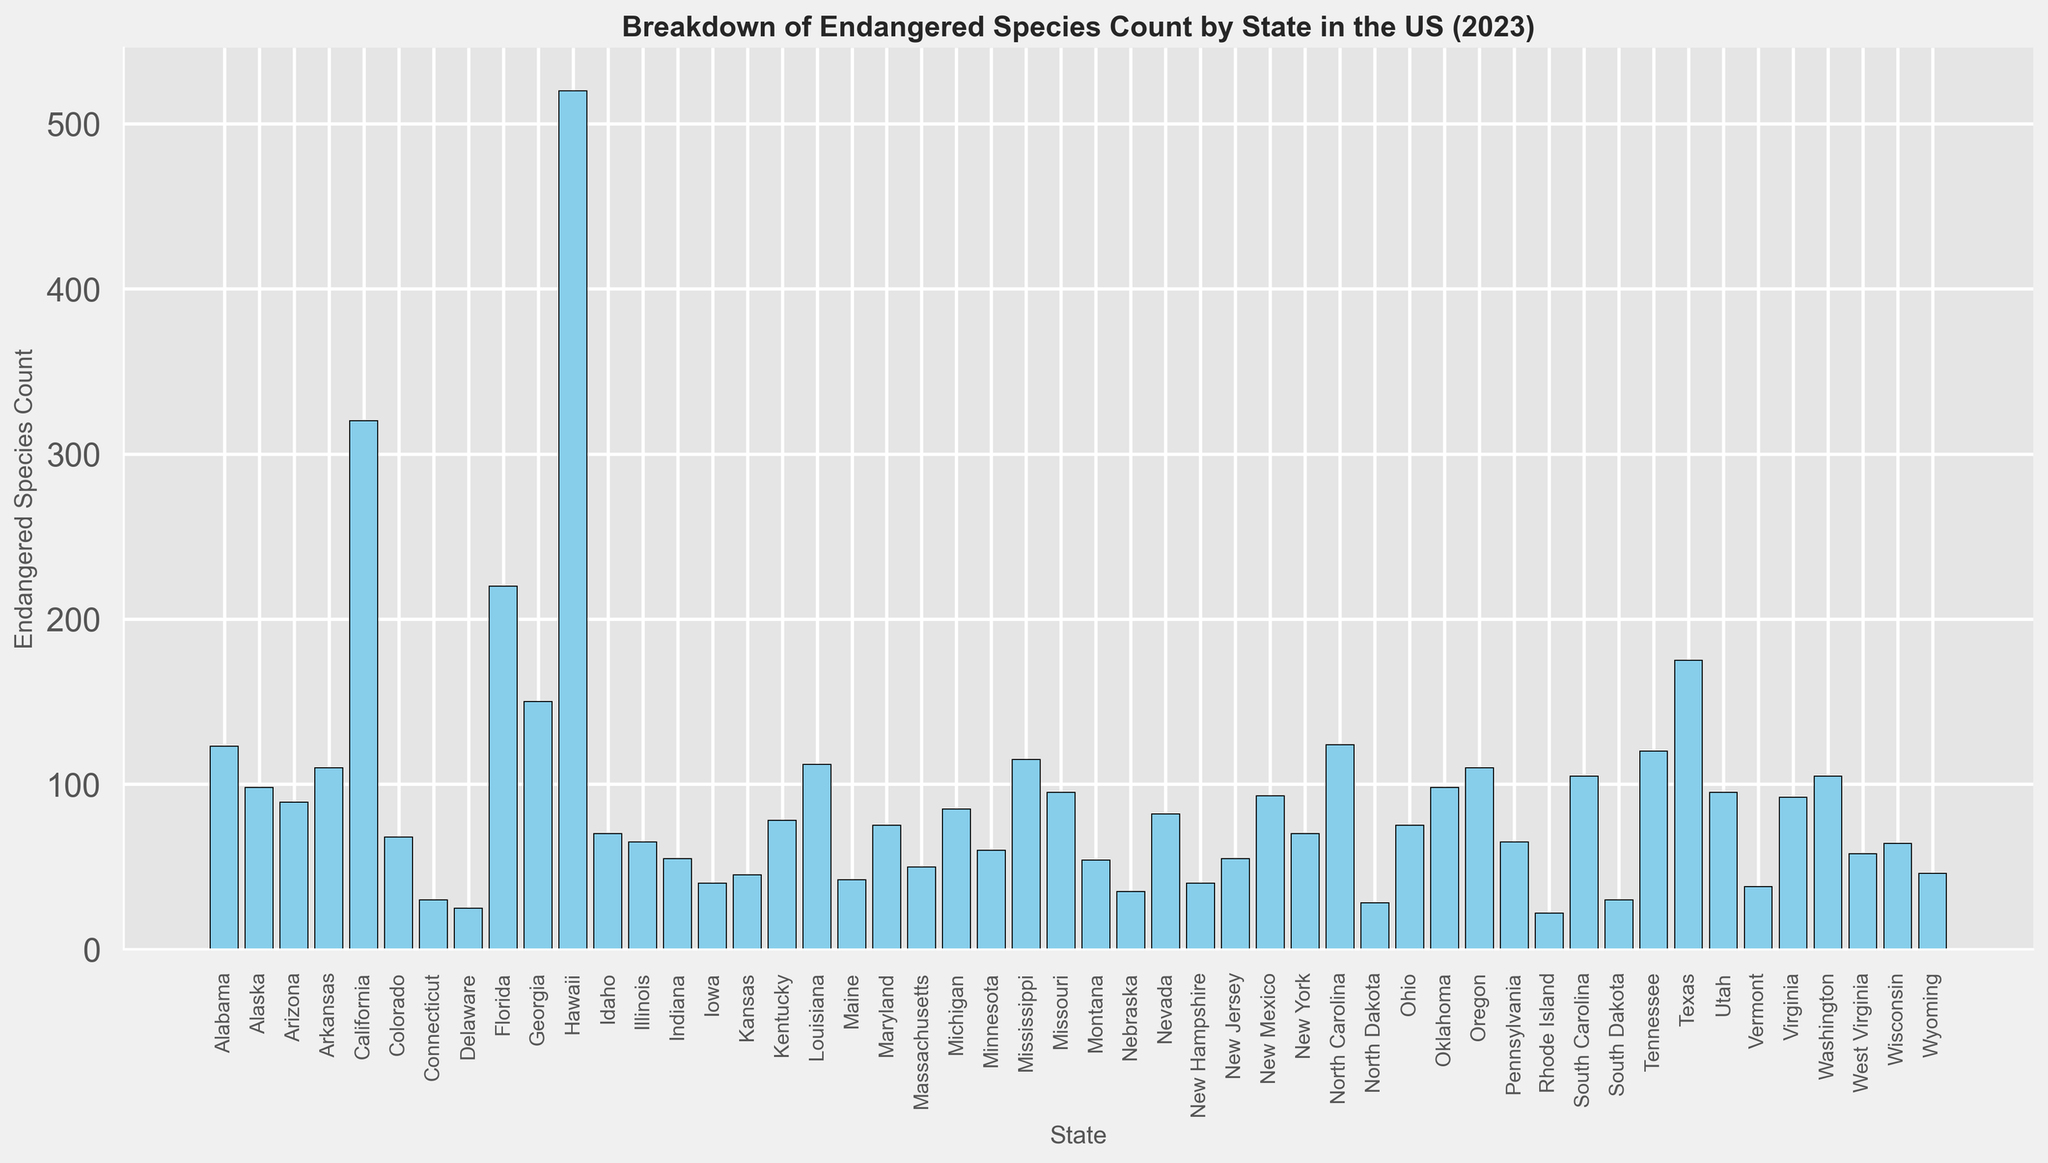What's the state with the highest count of endangered species? To find the state with the highest count, look for the tallest bar in the chart, which represents Hawaii with 520 endangered species.
Answer: Hawaii Which states have an endangered species count greater than 100 but less than 200? Identify the bars that fall within the range of 100 to 200. These states are Georgia (150), Tennessee (120), Texas (175), and North Carolina (124).
Answer: Georgia, Tennessee, Texas, North Carolina How does the endangered species count in California compare to that in Texas? Compare the heights of the bars for California and Texas. California has 320 endangered species, while Texas has 175. Thus, California has more endangered species than Texas.
Answer: California has more How many states have more than 200 endangered species? Count the bars that exceed the height representing 200 endangered species. There are three states: California (320), Florida (220), and Hawaii (520).
Answer: 3 What is the combined endangered species count for Nevada and Arizona? Add the counts for Nevada (82) and Arizona (89). The sum is 82 + 89 = 171.
Answer: 171 Which state has the lowest count of endangered species? Look for the shortest bar. Rhode Island has the fewest with 22 endangered species.
Answer: Rhode Island How many states have endangered species counts between 50 and 100 inclusive? Count the bars that fall within the range of 50 to 100. These states are Alaska (98), Colorado (68), Idaho (70), Illinois (65), Indiana (55), Kansas (45), Michigan (85), Minnesota (60), Missouri (95), Montana (54), Nebraska (35), Nevada (82), New Hampshire (40), New Jersey (55), New Mexico (93), Ohio (75), Oklahoma (98), Pennsylvania (65), Virginia (92), Washington (105), West Virginia (58), Wisconsin (64), Wyoming (46). That's 23 states.
Answer: 23 Between Florida and Hawaii, which state has a higher endangered species count? Compare the bars for Florida and Hawaii. Florida has 220 endangered species, whereas Hawaii has 520. Thus, Hawaii has a higher count.
Answer: Hawaii What is the difference in endangered species count between Alabama and Kentucky? Subtract the count for Kentucky (78) from Alabama (123). The difference is 123 - 78 = 45.
Answer: 45 What's the average endangered species count across all states? Sum the endangered species counts for all the states and divide by the number of states (50). The total is 4233 and the average is 4233 / 50 = 84.66.
Answer: 84.66 